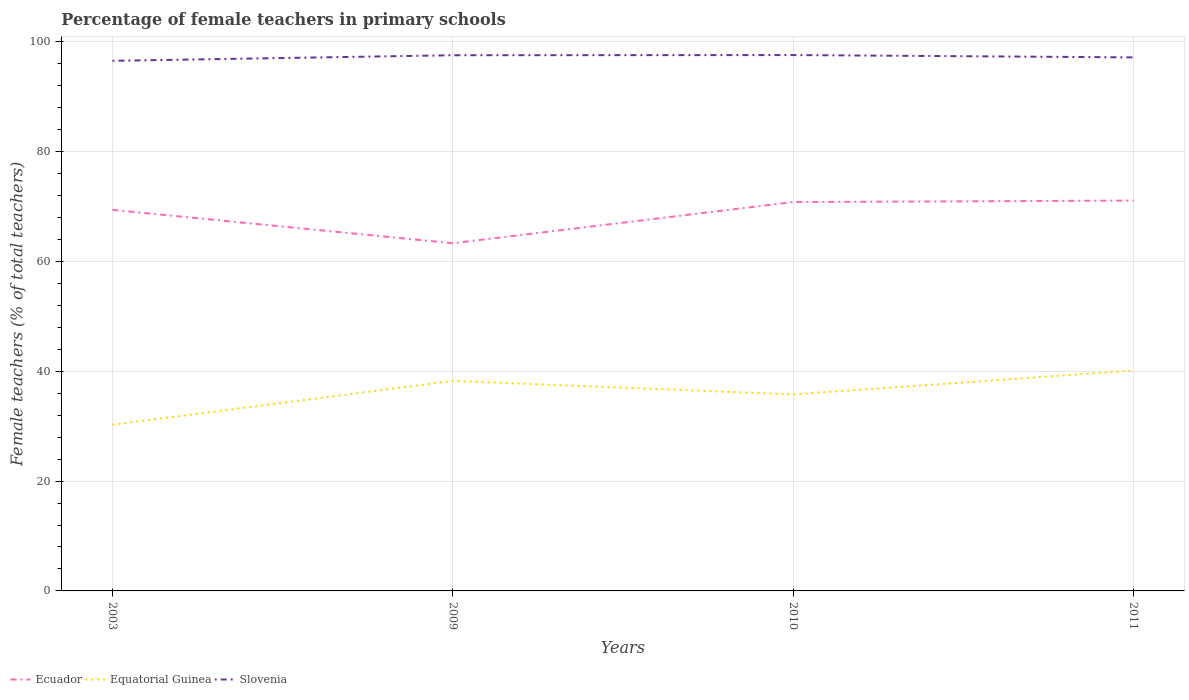How many different coloured lines are there?
Offer a terse response. 3. Does the line corresponding to Ecuador intersect with the line corresponding to Slovenia?
Keep it short and to the point. No. Is the number of lines equal to the number of legend labels?
Provide a short and direct response. Yes. Across all years, what is the maximum percentage of female teachers in Equatorial Guinea?
Your answer should be compact. 30.26. What is the total percentage of female teachers in Equatorial Guinea in the graph?
Provide a short and direct response. 2.46. What is the difference between the highest and the second highest percentage of female teachers in Slovenia?
Offer a terse response. 1.05. What is the difference between the highest and the lowest percentage of female teachers in Equatorial Guinea?
Your response must be concise. 2. Is the percentage of female teachers in Slovenia strictly greater than the percentage of female teachers in Equatorial Guinea over the years?
Your answer should be very brief. No. How many lines are there?
Offer a very short reply. 3. How many years are there in the graph?
Your answer should be very brief. 4. What is the difference between two consecutive major ticks on the Y-axis?
Give a very brief answer. 20. Are the values on the major ticks of Y-axis written in scientific E-notation?
Provide a succinct answer. No. Does the graph contain grids?
Make the answer very short. Yes. Where does the legend appear in the graph?
Offer a terse response. Bottom left. How are the legend labels stacked?
Make the answer very short. Horizontal. What is the title of the graph?
Your response must be concise. Percentage of female teachers in primary schools. Does "Portugal" appear as one of the legend labels in the graph?
Give a very brief answer. No. What is the label or title of the Y-axis?
Ensure brevity in your answer.  Female teachers (% of total teachers). What is the Female teachers (% of total teachers) of Ecuador in 2003?
Keep it short and to the point. 69.37. What is the Female teachers (% of total teachers) in Equatorial Guinea in 2003?
Provide a succinct answer. 30.26. What is the Female teachers (% of total teachers) of Slovenia in 2003?
Your answer should be compact. 96.5. What is the Female teachers (% of total teachers) of Ecuador in 2009?
Provide a short and direct response. 63.29. What is the Female teachers (% of total teachers) of Equatorial Guinea in 2009?
Offer a terse response. 38.23. What is the Female teachers (% of total teachers) in Slovenia in 2009?
Your answer should be compact. 97.52. What is the Female teachers (% of total teachers) in Ecuador in 2010?
Provide a short and direct response. 70.79. What is the Female teachers (% of total teachers) of Equatorial Guinea in 2010?
Provide a succinct answer. 35.77. What is the Female teachers (% of total teachers) of Slovenia in 2010?
Provide a succinct answer. 97.55. What is the Female teachers (% of total teachers) in Ecuador in 2011?
Make the answer very short. 71.06. What is the Female teachers (% of total teachers) of Equatorial Guinea in 2011?
Make the answer very short. 40.12. What is the Female teachers (% of total teachers) of Slovenia in 2011?
Make the answer very short. 97.13. Across all years, what is the maximum Female teachers (% of total teachers) of Ecuador?
Keep it short and to the point. 71.06. Across all years, what is the maximum Female teachers (% of total teachers) in Equatorial Guinea?
Your answer should be compact. 40.12. Across all years, what is the maximum Female teachers (% of total teachers) of Slovenia?
Ensure brevity in your answer.  97.55. Across all years, what is the minimum Female teachers (% of total teachers) of Ecuador?
Give a very brief answer. 63.29. Across all years, what is the minimum Female teachers (% of total teachers) in Equatorial Guinea?
Keep it short and to the point. 30.26. Across all years, what is the minimum Female teachers (% of total teachers) of Slovenia?
Your answer should be very brief. 96.5. What is the total Female teachers (% of total teachers) in Ecuador in the graph?
Your response must be concise. 274.51. What is the total Female teachers (% of total teachers) in Equatorial Guinea in the graph?
Keep it short and to the point. 144.37. What is the total Female teachers (% of total teachers) in Slovenia in the graph?
Your response must be concise. 388.69. What is the difference between the Female teachers (% of total teachers) of Ecuador in 2003 and that in 2009?
Ensure brevity in your answer.  6.08. What is the difference between the Female teachers (% of total teachers) of Equatorial Guinea in 2003 and that in 2009?
Keep it short and to the point. -7.98. What is the difference between the Female teachers (% of total teachers) in Slovenia in 2003 and that in 2009?
Offer a terse response. -1.02. What is the difference between the Female teachers (% of total teachers) in Ecuador in 2003 and that in 2010?
Make the answer very short. -1.42. What is the difference between the Female teachers (% of total teachers) in Equatorial Guinea in 2003 and that in 2010?
Your answer should be very brief. -5.52. What is the difference between the Female teachers (% of total teachers) of Slovenia in 2003 and that in 2010?
Provide a succinct answer. -1.05. What is the difference between the Female teachers (% of total teachers) of Ecuador in 2003 and that in 2011?
Your answer should be very brief. -1.69. What is the difference between the Female teachers (% of total teachers) in Equatorial Guinea in 2003 and that in 2011?
Offer a terse response. -9.86. What is the difference between the Female teachers (% of total teachers) in Slovenia in 2003 and that in 2011?
Keep it short and to the point. -0.63. What is the difference between the Female teachers (% of total teachers) of Ecuador in 2009 and that in 2010?
Your answer should be compact. -7.5. What is the difference between the Female teachers (% of total teachers) in Equatorial Guinea in 2009 and that in 2010?
Your answer should be compact. 2.46. What is the difference between the Female teachers (% of total teachers) of Slovenia in 2009 and that in 2010?
Give a very brief answer. -0.03. What is the difference between the Female teachers (% of total teachers) in Ecuador in 2009 and that in 2011?
Offer a very short reply. -7.77. What is the difference between the Female teachers (% of total teachers) of Equatorial Guinea in 2009 and that in 2011?
Your answer should be compact. -1.88. What is the difference between the Female teachers (% of total teachers) in Slovenia in 2009 and that in 2011?
Offer a terse response. 0.39. What is the difference between the Female teachers (% of total teachers) in Ecuador in 2010 and that in 2011?
Provide a short and direct response. -0.27. What is the difference between the Female teachers (% of total teachers) of Equatorial Guinea in 2010 and that in 2011?
Your answer should be very brief. -4.34. What is the difference between the Female teachers (% of total teachers) of Slovenia in 2010 and that in 2011?
Offer a terse response. 0.42. What is the difference between the Female teachers (% of total teachers) in Ecuador in 2003 and the Female teachers (% of total teachers) in Equatorial Guinea in 2009?
Give a very brief answer. 31.14. What is the difference between the Female teachers (% of total teachers) in Ecuador in 2003 and the Female teachers (% of total teachers) in Slovenia in 2009?
Your response must be concise. -28.15. What is the difference between the Female teachers (% of total teachers) in Equatorial Guinea in 2003 and the Female teachers (% of total teachers) in Slovenia in 2009?
Your answer should be compact. -67.26. What is the difference between the Female teachers (% of total teachers) in Ecuador in 2003 and the Female teachers (% of total teachers) in Equatorial Guinea in 2010?
Your answer should be compact. 33.6. What is the difference between the Female teachers (% of total teachers) of Ecuador in 2003 and the Female teachers (% of total teachers) of Slovenia in 2010?
Make the answer very short. -28.18. What is the difference between the Female teachers (% of total teachers) of Equatorial Guinea in 2003 and the Female teachers (% of total teachers) of Slovenia in 2010?
Offer a terse response. -67.29. What is the difference between the Female teachers (% of total teachers) in Ecuador in 2003 and the Female teachers (% of total teachers) in Equatorial Guinea in 2011?
Your response must be concise. 29.25. What is the difference between the Female teachers (% of total teachers) of Ecuador in 2003 and the Female teachers (% of total teachers) of Slovenia in 2011?
Give a very brief answer. -27.76. What is the difference between the Female teachers (% of total teachers) of Equatorial Guinea in 2003 and the Female teachers (% of total teachers) of Slovenia in 2011?
Keep it short and to the point. -66.87. What is the difference between the Female teachers (% of total teachers) in Ecuador in 2009 and the Female teachers (% of total teachers) in Equatorial Guinea in 2010?
Your answer should be compact. 27.52. What is the difference between the Female teachers (% of total teachers) in Ecuador in 2009 and the Female teachers (% of total teachers) in Slovenia in 2010?
Your response must be concise. -34.26. What is the difference between the Female teachers (% of total teachers) of Equatorial Guinea in 2009 and the Female teachers (% of total teachers) of Slovenia in 2010?
Your response must be concise. -59.32. What is the difference between the Female teachers (% of total teachers) in Ecuador in 2009 and the Female teachers (% of total teachers) in Equatorial Guinea in 2011?
Keep it short and to the point. 23.18. What is the difference between the Female teachers (% of total teachers) of Ecuador in 2009 and the Female teachers (% of total teachers) of Slovenia in 2011?
Your response must be concise. -33.83. What is the difference between the Female teachers (% of total teachers) of Equatorial Guinea in 2009 and the Female teachers (% of total teachers) of Slovenia in 2011?
Provide a succinct answer. -58.89. What is the difference between the Female teachers (% of total teachers) of Ecuador in 2010 and the Female teachers (% of total teachers) of Equatorial Guinea in 2011?
Your answer should be very brief. 30.67. What is the difference between the Female teachers (% of total teachers) in Ecuador in 2010 and the Female teachers (% of total teachers) in Slovenia in 2011?
Offer a terse response. -26.34. What is the difference between the Female teachers (% of total teachers) of Equatorial Guinea in 2010 and the Female teachers (% of total teachers) of Slovenia in 2011?
Provide a succinct answer. -61.35. What is the average Female teachers (% of total teachers) in Ecuador per year?
Make the answer very short. 68.63. What is the average Female teachers (% of total teachers) of Equatorial Guinea per year?
Make the answer very short. 36.09. What is the average Female teachers (% of total teachers) of Slovenia per year?
Keep it short and to the point. 97.17. In the year 2003, what is the difference between the Female teachers (% of total teachers) of Ecuador and Female teachers (% of total teachers) of Equatorial Guinea?
Ensure brevity in your answer.  39.11. In the year 2003, what is the difference between the Female teachers (% of total teachers) of Ecuador and Female teachers (% of total teachers) of Slovenia?
Ensure brevity in your answer.  -27.13. In the year 2003, what is the difference between the Female teachers (% of total teachers) in Equatorial Guinea and Female teachers (% of total teachers) in Slovenia?
Your answer should be very brief. -66.24. In the year 2009, what is the difference between the Female teachers (% of total teachers) of Ecuador and Female teachers (% of total teachers) of Equatorial Guinea?
Offer a very short reply. 25.06. In the year 2009, what is the difference between the Female teachers (% of total teachers) in Ecuador and Female teachers (% of total teachers) in Slovenia?
Ensure brevity in your answer.  -34.23. In the year 2009, what is the difference between the Female teachers (% of total teachers) in Equatorial Guinea and Female teachers (% of total teachers) in Slovenia?
Offer a very short reply. -59.29. In the year 2010, what is the difference between the Female teachers (% of total teachers) in Ecuador and Female teachers (% of total teachers) in Equatorial Guinea?
Provide a short and direct response. 35.02. In the year 2010, what is the difference between the Female teachers (% of total teachers) in Ecuador and Female teachers (% of total teachers) in Slovenia?
Keep it short and to the point. -26.76. In the year 2010, what is the difference between the Female teachers (% of total teachers) of Equatorial Guinea and Female teachers (% of total teachers) of Slovenia?
Provide a short and direct response. -61.78. In the year 2011, what is the difference between the Female teachers (% of total teachers) in Ecuador and Female teachers (% of total teachers) in Equatorial Guinea?
Your answer should be very brief. 30.94. In the year 2011, what is the difference between the Female teachers (% of total teachers) of Ecuador and Female teachers (% of total teachers) of Slovenia?
Your answer should be very brief. -26.07. In the year 2011, what is the difference between the Female teachers (% of total teachers) of Equatorial Guinea and Female teachers (% of total teachers) of Slovenia?
Give a very brief answer. -57.01. What is the ratio of the Female teachers (% of total teachers) in Ecuador in 2003 to that in 2009?
Keep it short and to the point. 1.1. What is the ratio of the Female teachers (% of total teachers) in Equatorial Guinea in 2003 to that in 2009?
Provide a succinct answer. 0.79. What is the ratio of the Female teachers (% of total teachers) of Ecuador in 2003 to that in 2010?
Your response must be concise. 0.98. What is the ratio of the Female teachers (% of total teachers) of Equatorial Guinea in 2003 to that in 2010?
Make the answer very short. 0.85. What is the ratio of the Female teachers (% of total teachers) in Slovenia in 2003 to that in 2010?
Give a very brief answer. 0.99. What is the ratio of the Female teachers (% of total teachers) of Ecuador in 2003 to that in 2011?
Ensure brevity in your answer.  0.98. What is the ratio of the Female teachers (% of total teachers) of Equatorial Guinea in 2003 to that in 2011?
Make the answer very short. 0.75. What is the ratio of the Female teachers (% of total teachers) of Slovenia in 2003 to that in 2011?
Ensure brevity in your answer.  0.99. What is the ratio of the Female teachers (% of total teachers) in Ecuador in 2009 to that in 2010?
Provide a succinct answer. 0.89. What is the ratio of the Female teachers (% of total teachers) in Equatorial Guinea in 2009 to that in 2010?
Offer a terse response. 1.07. What is the ratio of the Female teachers (% of total teachers) in Ecuador in 2009 to that in 2011?
Offer a very short reply. 0.89. What is the ratio of the Female teachers (% of total teachers) of Equatorial Guinea in 2009 to that in 2011?
Your response must be concise. 0.95. What is the ratio of the Female teachers (% of total teachers) of Equatorial Guinea in 2010 to that in 2011?
Your answer should be compact. 0.89. What is the ratio of the Female teachers (% of total teachers) of Slovenia in 2010 to that in 2011?
Your answer should be compact. 1. What is the difference between the highest and the second highest Female teachers (% of total teachers) of Ecuador?
Make the answer very short. 0.27. What is the difference between the highest and the second highest Female teachers (% of total teachers) of Equatorial Guinea?
Offer a very short reply. 1.88. What is the difference between the highest and the second highest Female teachers (% of total teachers) in Slovenia?
Offer a terse response. 0.03. What is the difference between the highest and the lowest Female teachers (% of total teachers) in Ecuador?
Offer a very short reply. 7.77. What is the difference between the highest and the lowest Female teachers (% of total teachers) in Equatorial Guinea?
Your response must be concise. 9.86. What is the difference between the highest and the lowest Female teachers (% of total teachers) in Slovenia?
Provide a short and direct response. 1.05. 